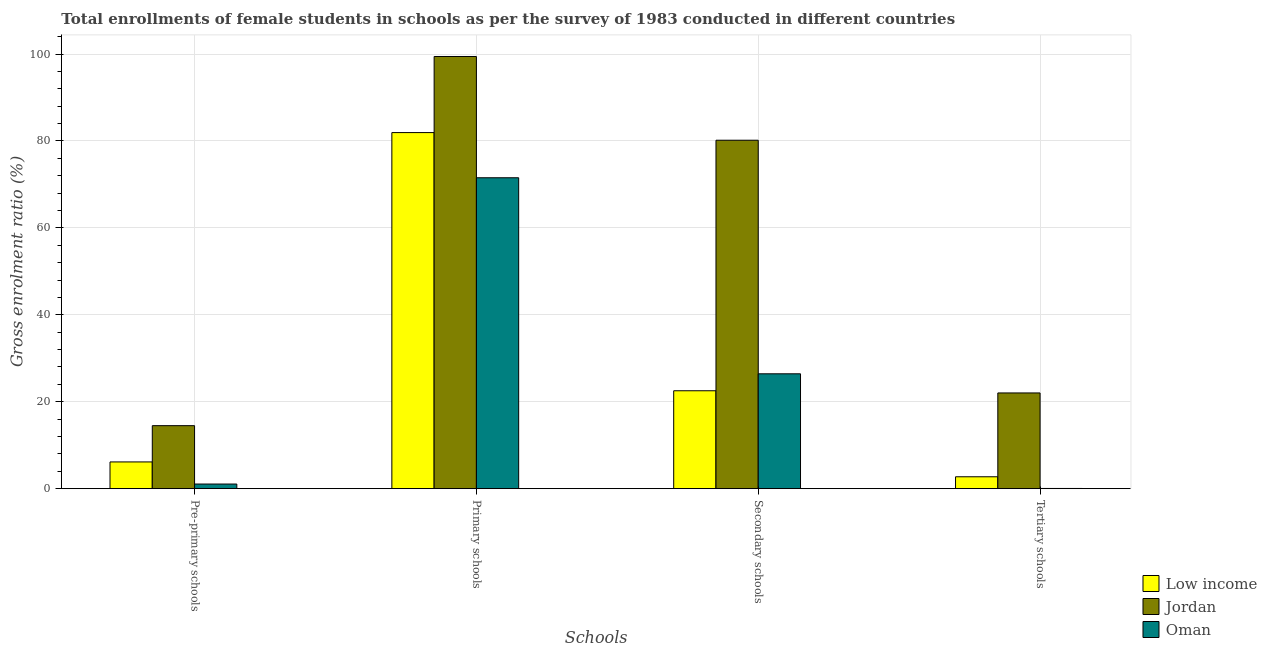How many groups of bars are there?
Keep it short and to the point. 4. What is the label of the 3rd group of bars from the left?
Your answer should be very brief. Secondary schools. What is the gross enrolment ratio(female) in primary schools in Jordan?
Make the answer very short. 99.43. Across all countries, what is the maximum gross enrolment ratio(female) in secondary schools?
Ensure brevity in your answer.  80.17. Across all countries, what is the minimum gross enrolment ratio(female) in secondary schools?
Keep it short and to the point. 22.53. In which country was the gross enrolment ratio(female) in pre-primary schools maximum?
Offer a very short reply. Jordan. In which country was the gross enrolment ratio(female) in tertiary schools minimum?
Ensure brevity in your answer.  Oman. What is the total gross enrolment ratio(female) in pre-primary schools in the graph?
Ensure brevity in your answer.  21.72. What is the difference between the gross enrolment ratio(female) in primary schools in Low income and that in Oman?
Make the answer very short. 10.39. What is the difference between the gross enrolment ratio(female) in secondary schools in Low income and the gross enrolment ratio(female) in pre-primary schools in Oman?
Offer a very short reply. 21.46. What is the average gross enrolment ratio(female) in pre-primary schools per country?
Ensure brevity in your answer.  7.24. What is the difference between the gross enrolment ratio(female) in tertiary schools and gross enrolment ratio(female) in pre-primary schools in Jordan?
Ensure brevity in your answer.  7.53. What is the ratio of the gross enrolment ratio(female) in pre-primary schools in Oman to that in Jordan?
Make the answer very short. 0.07. Is the gross enrolment ratio(female) in primary schools in Oman less than that in Jordan?
Your answer should be very brief. Yes. Is the difference between the gross enrolment ratio(female) in primary schools in Low income and Jordan greater than the difference between the gross enrolment ratio(female) in tertiary schools in Low income and Jordan?
Offer a terse response. Yes. What is the difference between the highest and the second highest gross enrolment ratio(female) in pre-primary schools?
Provide a short and direct response. 8.34. What is the difference between the highest and the lowest gross enrolment ratio(female) in secondary schools?
Your response must be concise. 57.64. In how many countries, is the gross enrolment ratio(female) in primary schools greater than the average gross enrolment ratio(female) in primary schools taken over all countries?
Ensure brevity in your answer.  1. Is the sum of the gross enrolment ratio(female) in tertiary schools in Low income and Oman greater than the maximum gross enrolment ratio(female) in secondary schools across all countries?
Ensure brevity in your answer.  No. What does the 2nd bar from the right in Primary schools represents?
Ensure brevity in your answer.  Jordan. Is it the case that in every country, the sum of the gross enrolment ratio(female) in pre-primary schools and gross enrolment ratio(female) in primary schools is greater than the gross enrolment ratio(female) in secondary schools?
Offer a terse response. Yes. Are all the bars in the graph horizontal?
Keep it short and to the point. No. What is the difference between two consecutive major ticks on the Y-axis?
Your answer should be very brief. 20. Are the values on the major ticks of Y-axis written in scientific E-notation?
Your response must be concise. No. Does the graph contain any zero values?
Provide a short and direct response. No. Does the graph contain grids?
Provide a succinct answer. Yes. Where does the legend appear in the graph?
Make the answer very short. Bottom right. How are the legend labels stacked?
Ensure brevity in your answer.  Vertical. What is the title of the graph?
Offer a very short reply. Total enrollments of female students in schools as per the survey of 1983 conducted in different countries. Does "Angola" appear as one of the legend labels in the graph?
Keep it short and to the point. No. What is the label or title of the X-axis?
Provide a short and direct response. Schools. What is the label or title of the Y-axis?
Ensure brevity in your answer.  Gross enrolment ratio (%). What is the Gross enrolment ratio (%) in Low income in Pre-primary schools?
Make the answer very short. 6.15. What is the Gross enrolment ratio (%) in Jordan in Pre-primary schools?
Your answer should be very brief. 14.5. What is the Gross enrolment ratio (%) of Oman in Pre-primary schools?
Provide a succinct answer. 1.07. What is the Gross enrolment ratio (%) of Low income in Primary schools?
Keep it short and to the point. 81.93. What is the Gross enrolment ratio (%) of Jordan in Primary schools?
Your response must be concise. 99.43. What is the Gross enrolment ratio (%) of Oman in Primary schools?
Your answer should be very brief. 71.53. What is the Gross enrolment ratio (%) of Low income in Secondary schools?
Make the answer very short. 22.53. What is the Gross enrolment ratio (%) of Jordan in Secondary schools?
Provide a short and direct response. 80.17. What is the Gross enrolment ratio (%) in Oman in Secondary schools?
Provide a succinct answer. 26.43. What is the Gross enrolment ratio (%) of Low income in Tertiary schools?
Keep it short and to the point. 2.74. What is the Gross enrolment ratio (%) in Jordan in Tertiary schools?
Your response must be concise. 22.02. What is the Gross enrolment ratio (%) in Oman in Tertiary schools?
Give a very brief answer. 0.05. Across all Schools, what is the maximum Gross enrolment ratio (%) of Low income?
Your answer should be very brief. 81.93. Across all Schools, what is the maximum Gross enrolment ratio (%) in Jordan?
Offer a terse response. 99.43. Across all Schools, what is the maximum Gross enrolment ratio (%) of Oman?
Provide a succinct answer. 71.53. Across all Schools, what is the minimum Gross enrolment ratio (%) of Low income?
Your answer should be very brief. 2.74. Across all Schools, what is the minimum Gross enrolment ratio (%) of Jordan?
Provide a short and direct response. 14.5. Across all Schools, what is the minimum Gross enrolment ratio (%) in Oman?
Your answer should be compact. 0.05. What is the total Gross enrolment ratio (%) of Low income in the graph?
Make the answer very short. 113.35. What is the total Gross enrolment ratio (%) in Jordan in the graph?
Make the answer very short. 216.12. What is the total Gross enrolment ratio (%) in Oman in the graph?
Keep it short and to the point. 99.07. What is the difference between the Gross enrolment ratio (%) of Low income in Pre-primary schools and that in Primary schools?
Keep it short and to the point. -75.77. What is the difference between the Gross enrolment ratio (%) in Jordan in Pre-primary schools and that in Primary schools?
Offer a very short reply. -84.94. What is the difference between the Gross enrolment ratio (%) in Oman in Pre-primary schools and that in Primary schools?
Offer a very short reply. -70.47. What is the difference between the Gross enrolment ratio (%) of Low income in Pre-primary schools and that in Secondary schools?
Offer a terse response. -16.37. What is the difference between the Gross enrolment ratio (%) of Jordan in Pre-primary schools and that in Secondary schools?
Offer a very short reply. -65.67. What is the difference between the Gross enrolment ratio (%) of Oman in Pre-primary schools and that in Secondary schools?
Offer a terse response. -25.36. What is the difference between the Gross enrolment ratio (%) of Low income in Pre-primary schools and that in Tertiary schools?
Give a very brief answer. 3.42. What is the difference between the Gross enrolment ratio (%) in Jordan in Pre-primary schools and that in Tertiary schools?
Keep it short and to the point. -7.53. What is the difference between the Gross enrolment ratio (%) of Oman in Pre-primary schools and that in Tertiary schools?
Your answer should be very brief. 1.02. What is the difference between the Gross enrolment ratio (%) of Low income in Primary schools and that in Secondary schools?
Provide a short and direct response. 59.4. What is the difference between the Gross enrolment ratio (%) in Jordan in Primary schools and that in Secondary schools?
Offer a terse response. 19.27. What is the difference between the Gross enrolment ratio (%) of Oman in Primary schools and that in Secondary schools?
Provide a succinct answer. 45.1. What is the difference between the Gross enrolment ratio (%) in Low income in Primary schools and that in Tertiary schools?
Provide a short and direct response. 79.19. What is the difference between the Gross enrolment ratio (%) in Jordan in Primary schools and that in Tertiary schools?
Your answer should be compact. 77.41. What is the difference between the Gross enrolment ratio (%) in Oman in Primary schools and that in Tertiary schools?
Your response must be concise. 71.48. What is the difference between the Gross enrolment ratio (%) of Low income in Secondary schools and that in Tertiary schools?
Provide a short and direct response. 19.79. What is the difference between the Gross enrolment ratio (%) in Jordan in Secondary schools and that in Tertiary schools?
Offer a very short reply. 58.14. What is the difference between the Gross enrolment ratio (%) of Oman in Secondary schools and that in Tertiary schools?
Provide a succinct answer. 26.38. What is the difference between the Gross enrolment ratio (%) in Low income in Pre-primary schools and the Gross enrolment ratio (%) in Jordan in Primary schools?
Your response must be concise. -93.28. What is the difference between the Gross enrolment ratio (%) in Low income in Pre-primary schools and the Gross enrolment ratio (%) in Oman in Primary schools?
Offer a terse response. -65.38. What is the difference between the Gross enrolment ratio (%) in Jordan in Pre-primary schools and the Gross enrolment ratio (%) in Oman in Primary schools?
Your response must be concise. -57.04. What is the difference between the Gross enrolment ratio (%) of Low income in Pre-primary schools and the Gross enrolment ratio (%) of Jordan in Secondary schools?
Provide a short and direct response. -74.01. What is the difference between the Gross enrolment ratio (%) in Low income in Pre-primary schools and the Gross enrolment ratio (%) in Oman in Secondary schools?
Make the answer very short. -20.27. What is the difference between the Gross enrolment ratio (%) in Jordan in Pre-primary schools and the Gross enrolment ratio (%) in Oman in Secondary schools?
Make the answer very short. -11.93. What is the difference between the Gross enrolment ratio (%) of Low income in Pre-primary schools and the Gross enrolment ratio (%) of Jordan in Tertiary schools?
Provide a short and direct response. -15.87. What is the difference between the Gross enrolment ratio (%) in Low income in Pre-primary schools and the Gross enrolment ratio (%) in Oman in Tertiary schools?
Offer a terse response. 6.11. What is the difference between the Gross enrolment ratio (%) in Jordan in Pre-primary schools and the Gross enrolment ratio (%) in Oman in Tertiary schools?
Ensure brevity in your answer.  14.45. What is the difference between the Gross enrolment ratio (%) in Low income in Primary schools and the Gross enrolment ratio (%) in Jordan in Secondary schools?
Your answer should be compact. 1.76. What is the difference between the Gross enrolment ratio (%) in Low income in Primary schools and the Gross enrolment ratio (%) in Oman in Secondary schools?
Make the answer very short. 55.5. What is the difference between the Gross enrolment ratio (%) in Jordan in Primary schools and the Gross enrolment ratio (%) in Oman in Secondary schools?
Keep it short and to the point. 73.01. What is the difference between the Gross enrolment ratio (%) of Low income in Primary schools and the Gross enrolment ratio (%) of Jordan in Tertiary schools?
Provide a short and direct response. 59.9. What is the difference between the Gross enrolment ratio (%) of Low income in Primary schools and the Gross enrolment ratio (%) of Oman in Tertiary schools?
Make the answer very short. 81.88. What is the difference between the Gross enrolment ratio (%) of Jordan in Primary schools and the Gross enrolment ratio (%) of Oman in Tertiary schools?
Your answer should be compact. 99.38. What is the difference between the Gross enrolment ratio (%) in Low income in Secondary schools and the Gross enrolment ratio (%) in Jordan in Tertiary schools?
Your answer should be very brief. 0.5. What is the difference between the Gross enrolment ratio (%) of Low income in Secondary schools and the Gross enrolment ratio (%) of Oman in Tertiary schools?
Ensure brevity in your answer.  22.48. What is the difference between the Gross enrolment ratio (%) of Jordan in Secondary schools and the Gross enrolment ratio (%) of Oman in Tertiary schools?
Offer a very short reply. 80.12. What is the average Gross enrolment ratio (%) in Low income per Schools?
Offer a terse response. 28.34. What is the average Gross enrolment ratio (%) in Jordan per Schools?
Your answer should be very brief. 54.03. What is the average Gross enrolment ratio (%) in Oman per Schools?
Your answer should be compact. 24.77. What is the difference between the Gross enrolment ratio (%) of Low income and Gross enrolment ratio (%) of Jordan in Pre-primary schools?
Your response must be concise. -8.34. What is the difference between the Gross enrolment ratio (%) in Low income and Gross enrolment ratio (%) in Oman in Pre-primary schools?
Offer a terse response. 5.09. What is the difference between the Gross enrolment ratio (%) of Jordan and Gross enrolment ratio (%) of Oman in Pre-primary schools?
Your answer should be very brief. 13.43. What is the difference between the Gross enrolment ratio (%) in Low income and Gross enrolment ratio (%) in Jordan in Primary schools?
Give a very brief answer. -17.51. What is the difference between the Gross enrolment ratio (%) of Low income and Gross enrolment ratio (%) of Oman in Primary schools?
Give a very brief answer. 10.39. What is the difference between the Gross enrolment ratio (%) of Jordan and Gross enrolment ratio (%) of Oman in Primary schools?
Provide a short and direct response. 27.9. What is the difference between the Gross enrolment ratio (%) of Low income and Gross enrolment ratio (%) of Jordan in Secondary schools?
Your answer should be very brief. -57.64. What is the difference between the Gross enrolment ratio (%) in Low income and Gross enrolment ratio (%) in Oman in Secondary schools?
Your response must be concise. -3.9. What is the difference between the Gross enrolment ratio (%) in Jordan and Gross enrolment ratio (%) in Oman in Secondary schools?
Keep it short and to the point. 53.74. What is the difference between the Gross enrolment ratio (%) in Low income and Gross enrolment ratio (%) in Jordan in Tertiary schools?
Ensure brevity in your answer.  -19.29. What is the difference between the Gross enrolment ratio (%) of Low income and Gross enrolment ratio (%) of Oman in Tertiary schools?
Your answer should be very brief. 2.69. What is the difference between the Gross enrolment ratio (%) in Jordan and Gross enrolment ratio (%) in Oman in Tertiary schools?
Your answer should be compact. 21.98. What is the ratio of the Gross enrolment ratio (%) in Low income in Pre-primary schools to that in Primary schools?
Provide a short and direct response. 0.08. What is the ratio of the Gross enrolment ratio (%) in Jordan in Pre-primary schools to that in Primary schools?
Offer a terse response. 0.15. What is the ratio of the Gross enrolment ratio (%) of Oman in Pre-primary schools to that in Primary schools?
Provide a succinct answer. 0.01. What is the ratio of the Gross enrolment ratio (%) in Low income in Pre-primary schools to that in Secondary schools?
Your answer should be very brief. 0.27. What is the ratio of the Gross enrolment ratio (%) in Jordan in Pre-primary schools to that in Secondary schools?
Ensure brevity in your answer.  0.18. What is the ratio of the Gross enrolment ratio (%) of Oman in Pre-primary schools to that in Secondary schools?
Make the answer very short. 0.04. What is the ratio of the Gross enrolment ratio (%) of Low income in Pre-primary schools to that in Tertiary schools?
Ensure brevity in your answer.  2.25. What is the ratio of the Gross enrolment ratio (%) of Jordan in Pre-primary schools to that in Tertiary schools?
Provide a succinct answer. 0.66. What is the ratio of the Gross enrolment ratio (%) of Oman in Pre-primary schools to that in Tertiary schools?
Offer a very short reply. 21.92. What is the ratio of the Gross enrolment ratio (%) of Low income in Primary schools to that in Secondary schools?
Your answer should be compact. 3.64. What is the ratio of the Gross enrolment ratio (%) of Jordan in Primary schools to that in Secondary schools?
Offer a terse response. 1.24. What is the ratio of the Gross enrolment ratio (%) of Oman in Primary schools to that in Secondary schools?
Your answer should be very brief. 2.71. What is the ratio of the Gross enrolment ratio (%) in Low income in Primary schools to that in Tertiary schools?
Make the answer very short. 29.92. What is the ratio of the Gross enrolment ratio (%) in Jordan in Primary schools to that in Tertiary schools?
Ensure brevity in your answer.  4.51. What is the ratio of the Gross enrolment ratio (%) in Oman in Primary schools to that in Tertiary schools?
Make the answer very short. 1470.33. What is the ratio of the Gross enrolment ratio (%) of Low income in Secondary schools to that in Tertiary schools?
Provide a short and direct response. 8.23. What is the ratio of the Gross enrolment ratio (%) of Jordan in Secondary schools to that in Tertiary schools?
Your response must be concise. 3.64. What is the ratio of the Gross enrolment ratio (%) in Oman in Secondary schools to that in Tertiary schools?
Your answer should be compact. 543.22. What is the difference between the highest and the second highest Gross enrolment ratio (%) in Low income?
Provide a short and direct response. 59.4. What is the difference between the highest and the second highest Gross enrolment ratio (%) of Jordan?
Provide a short and direct response. 19.27. What is the difference between the highest and the second highest Gross enrolment ratio (%) of Oman?
Give a very brief answer. 45.1. What is the difference between the highest and the lowest Gross enrolment ratio (%) in Low income?
Give a very brief answer. 79.19. What is the difference between the highest and the lowest Gross enrolment ratio (%) of Jordan?
Give a very brief answer. 84.94. What is the difference between the highest and the lowest Gross enrolment ratio (%) in Oman?
Keep it short and to the point. 71.48. 